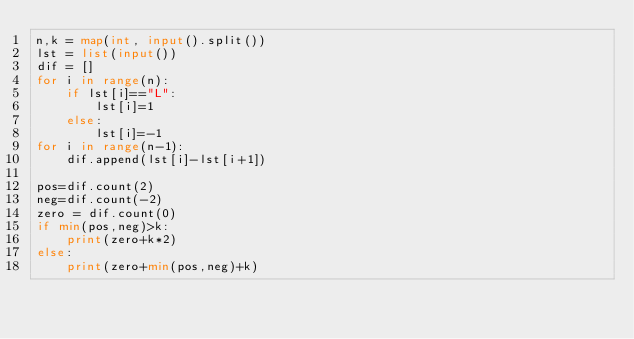<code> <loc_0><loc_0><loc_500><loc_500><_Python_>n,k = map(int, input().split())
lst = list(input())
dif = []
for i in range(n):
    if lst[i]=="L":
        lst[i]=1
    else:
        lst[i]=-1
for i in range(n-1):
    dif.append(lst[i]-lst[i+1])

pos=dif.count(2)
neg=dif.count(-2)
zero = dif.count(0)
if min(pos,neg)>k:
    print(zero+k*2)
else:
    print(zero+min(pos,neg)+k)
</code> 